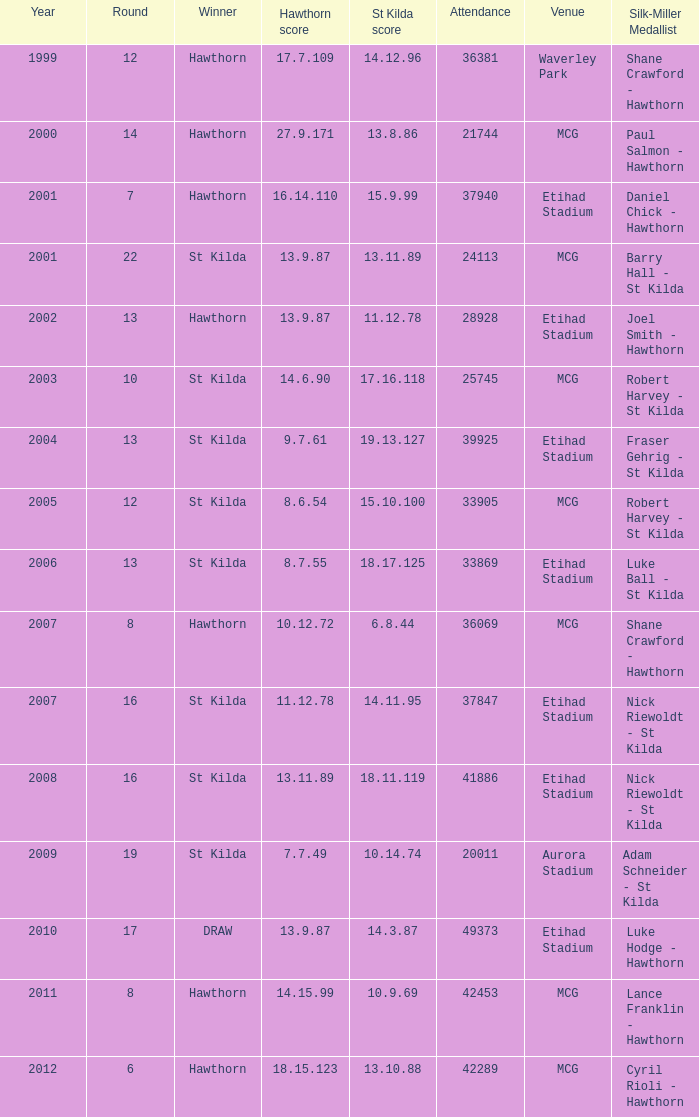How many individuals are in attendance with a hawthorn score of 18.15.123? 42289.0. 